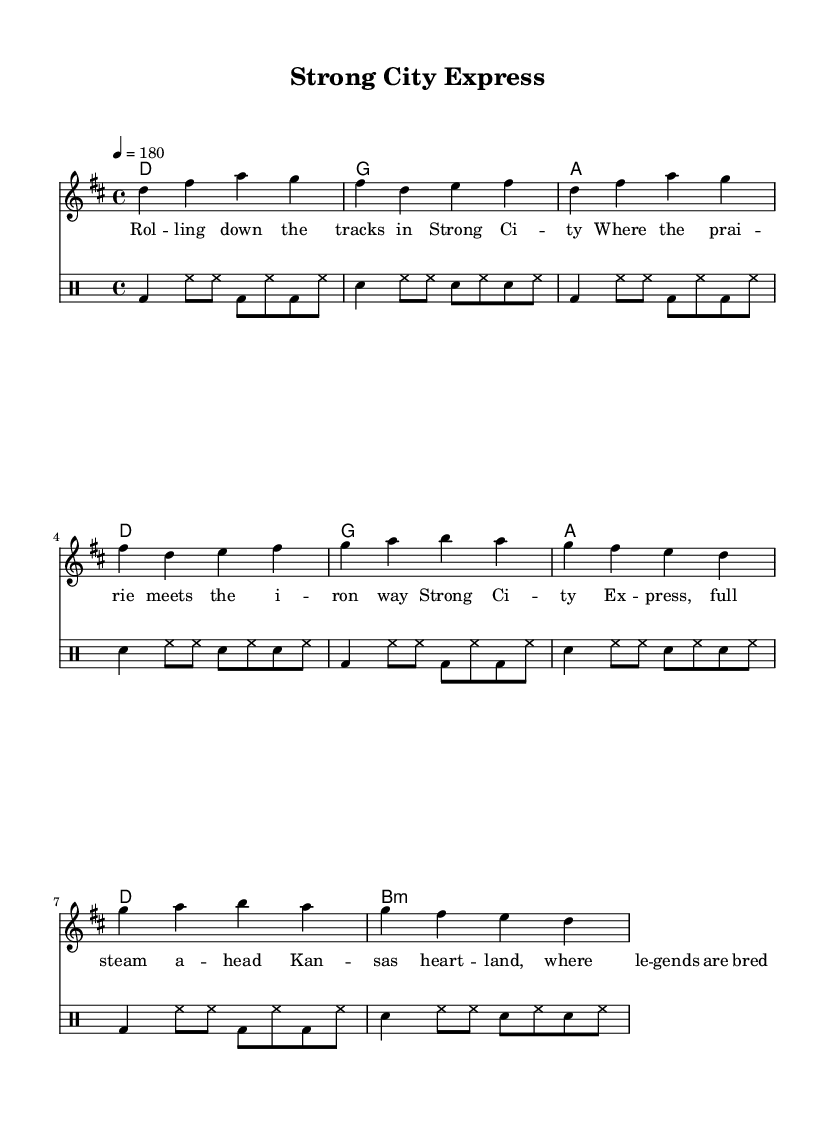What is the key signature of this music? The key signature is indicated at the beginning of the staff, showing two sharps. This indicates that the music is in D major, which has F# and C# as its sharps.
Answer: D major What is the time signature of the piece? The time signature is found at the beginning of the staff, shown as a fraction with a 4 on top and a 4 on the bottom, which means the piece is in common time (4/4).
Answer: 4/4 What is the tempo marking for the piece? The tempo is shown at the beginning of the staff with the marking "4 = 180," meaning there are 180 beats per minute, indicating a fast-paced tempo suitable for punk music.
Answer: 180 How many measures are in the verse section? By counting the measures marked for the verse, we see there are two repeated sections, each containing 4 measures, resulting in a total of 8 measures.
Answer: 8 What chords are used in the chorus? The chord chart above the staff shows g, a, b, and d as the chords played during the chorus section. This is derived from both the chord names and their positions above the corresponding measures.
Answer: g a b d What is the primary theme of the lyrics? The lyrics describe the experience of traveling through Strong City, Kansas, painting a picture of the local landscape and cultural significance, which is common in punk music that celebrates local life.
Answer: Small-town life What rhythmic elements are used in the drum part? The drum part includes a pattern repeated four times, showcasing a combination of bass drum, snare drum, and hi-hat notations, which is typical in punk music for driving energy and excitement.
Answer: Bass and snare 